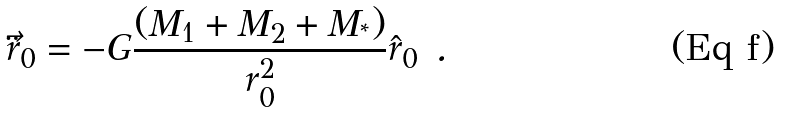<formula> <loc_0><loc_0><loc_500><loc_500>\ddot { \vec { r } } _ { 0 } = - G \frac { ( M _ { 1 } + M _ { 2 } + M _ { ^ { * } } ) } { r _ { 0 } ^ { 2 } } \hat { r } _ { 0 } \ .</formula> 